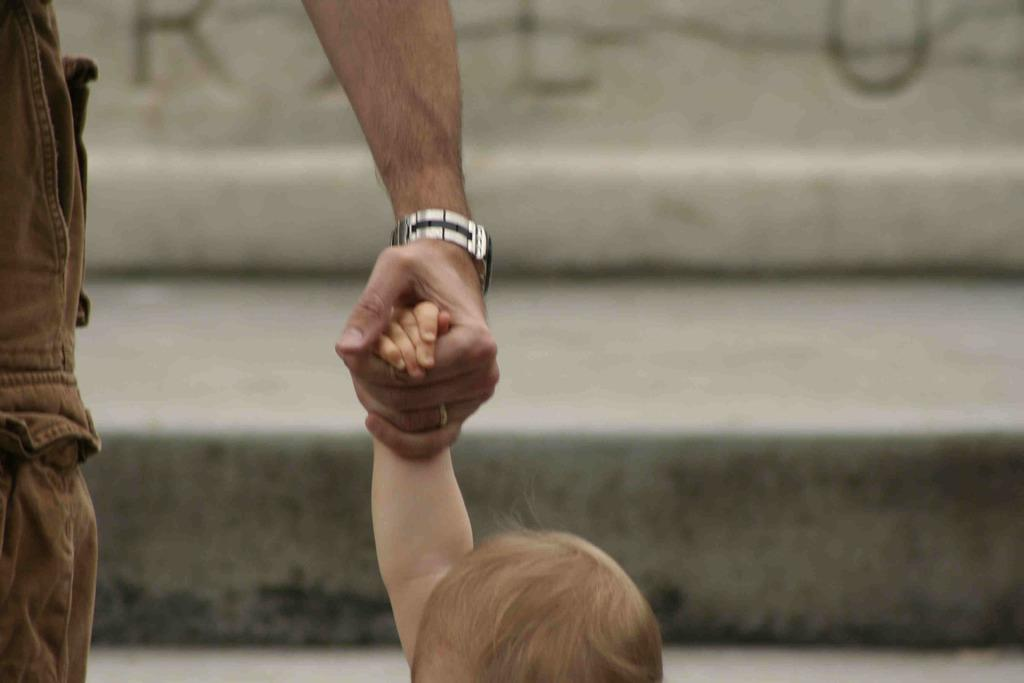What is the main subject of the image? There is a person in the image. What is the person doing in the image? The person is holding a baby's hand. Can you describe the background of the image? The background of the image is blurred. What color is the balloon in the image? There is no balloon present in the image. What memory does the person have of the baby in the image? The image does not provide any information about the person's memories or thoughts. 